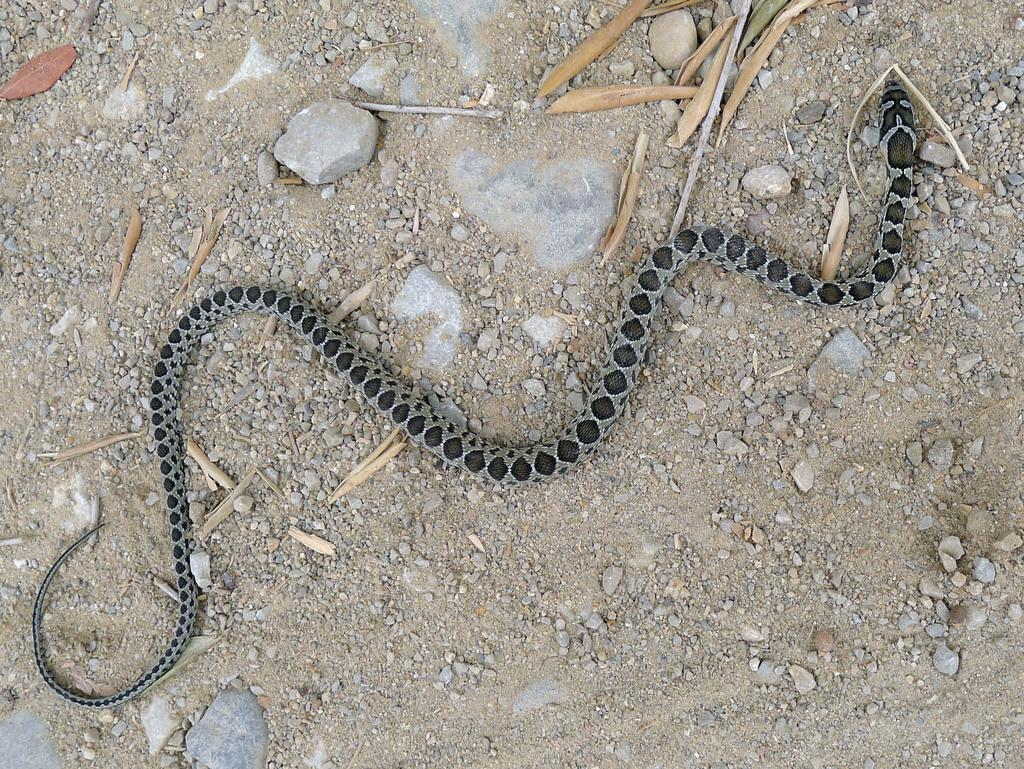What animal is depicted on the ground in the image? There is a snake represented on the ground in the image. What other objects can be seen in the image? There are stones and leaves present in the image. How many pigs are serving the snake in the image? There are no pigs or any indication of serving in the image; it only features a snake, stones, and leaves. 